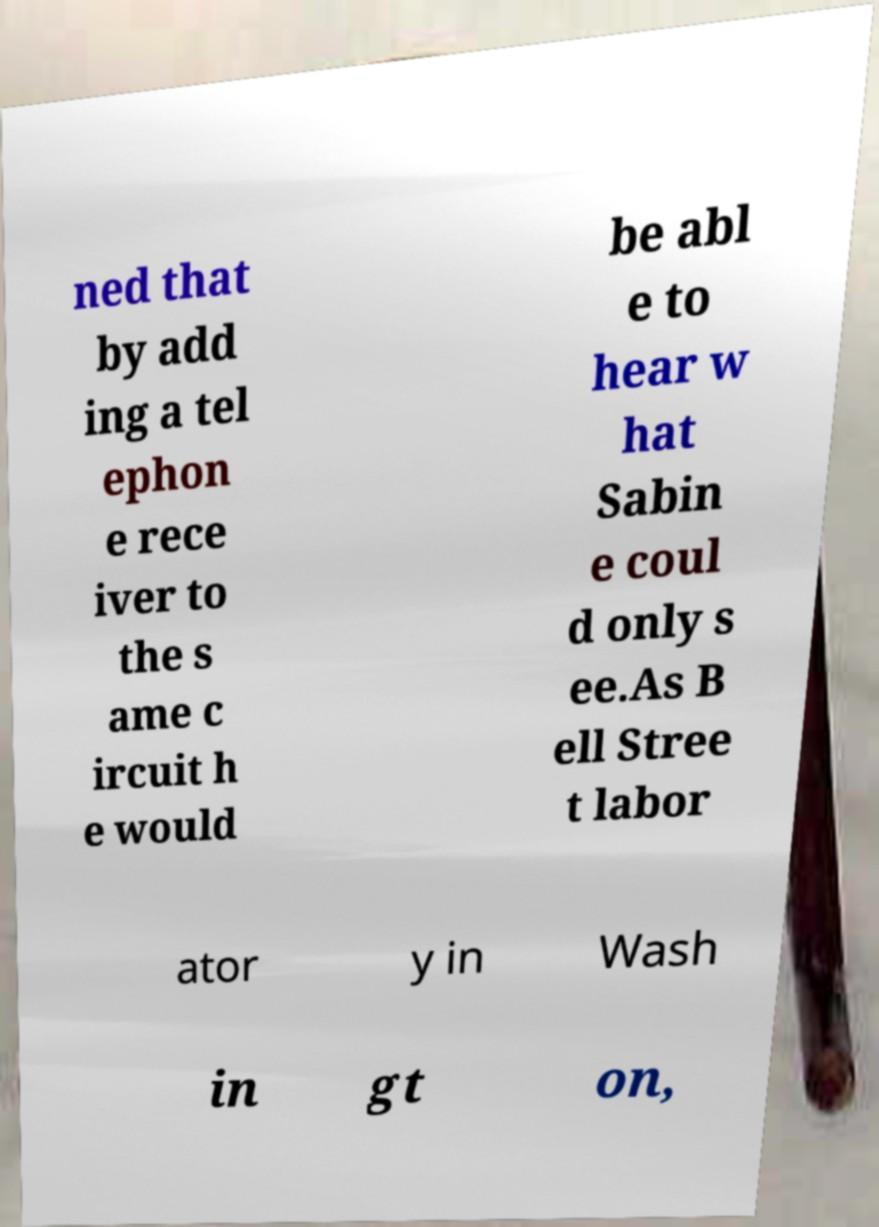What messages or text are displayed in this image? I need them in a readable, typed format. ned that by add ing a tel ephon e rece iver to the s ame c ircuit h e would be abl e to hear w hat Sabin e coul d only s ee.As B ell Stree t labor ator y in Wash in gt on, 